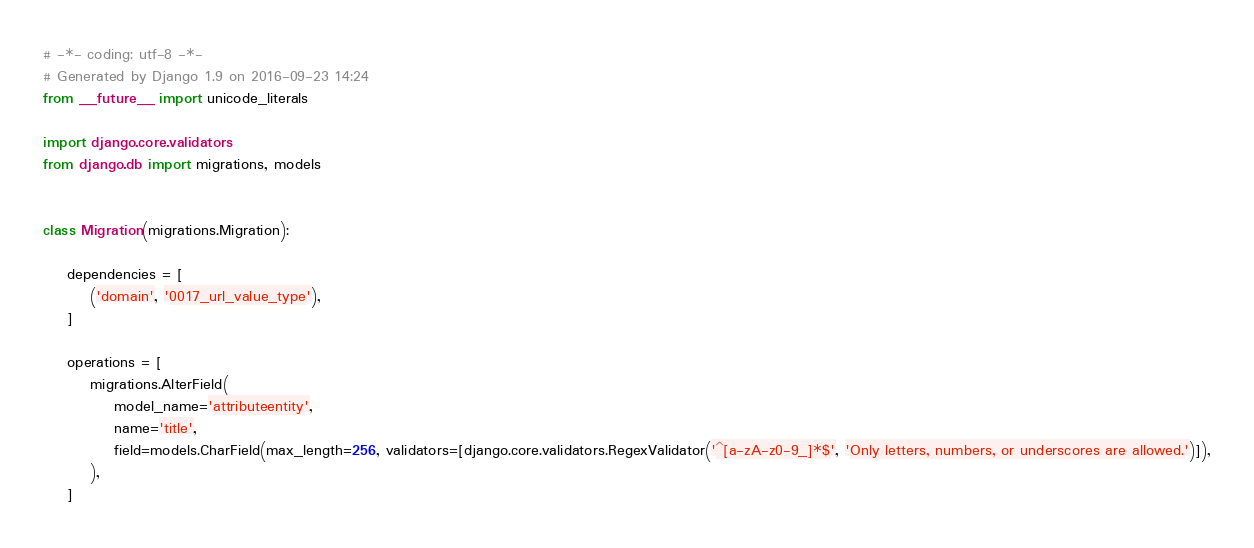<code> <loc_0><loc_0><loc_500><loc_500><_Python_># -*- coding: utf-8 -*-
# Generated by Django 1.9 on 2016-09-23 14:24
from __future__ import unicode_literals

import django.core.validators
from django.db import migrations, models


class Migration(migrations.Migration):

    dependencies = [
        ('domain', '0017_url_value_type'),
    ]

    operations = [
        migrations.AlterField(
            model_name='attributeentity',
            name='title',
            field=models.CharField(max_length=256, validators=[django.core.validators.RegexValidator('^[a-zA-z0-9_]*$', 'Only letters, numbers, or underscores are allowed.')]),
        ),
    ]
</code> 